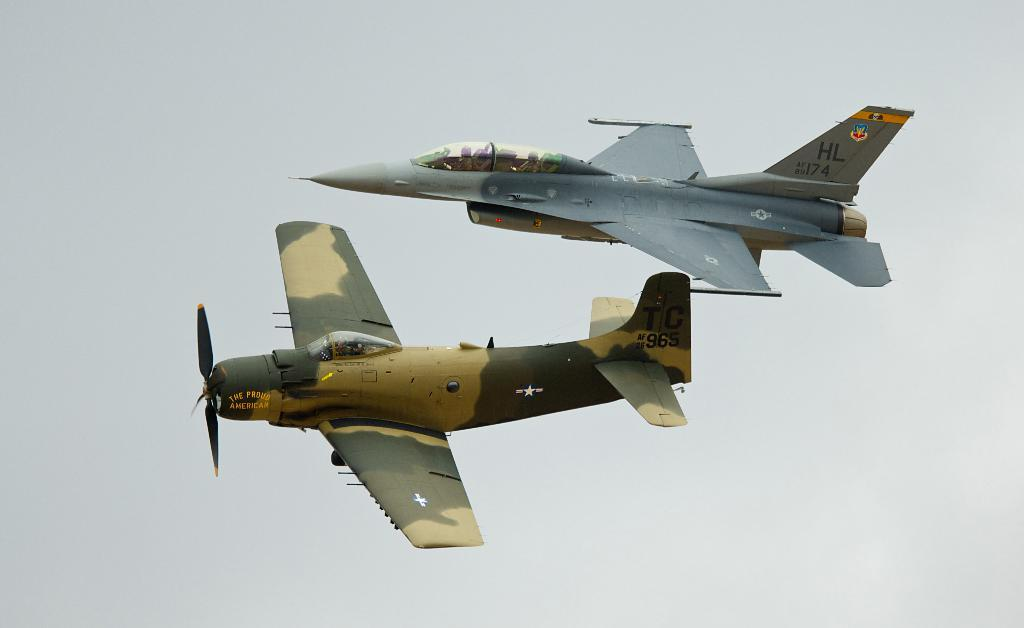<image>
Give a short and clear explanation of the subsequent image. Two planes flying next to each other, one is named the proud american 